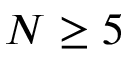<formula> <loc_0><loc_0><loc_500><loc_500>N \geq 5</formula> 